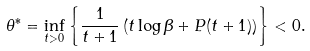<formula> <loc_0><loc_0><loc_500><loc_500>\theta ^ { \ast } = \inf _ { t > 0 } \left \{ \frac { 1 } { t + 1 } \left ( t \log \beta + P ( t + 1 ) \right ) \right \} < 0 .</formula> 